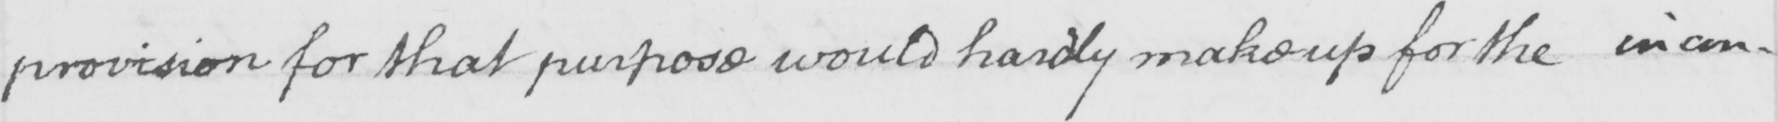Transcribe the text shown in this historical manuscript line. provision for that purpose would hardly make up for the incon- 